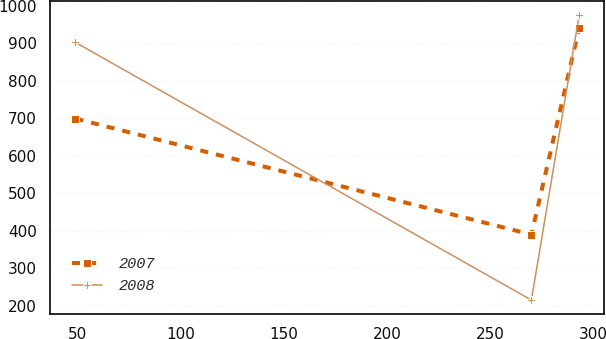Convert chart to OTSL. <chart><loc_0><loc_0><loc_500><loc_500><line_chart><ecel><fcel>2007<fcel>2008<nl><fcel>49.19<fcel>699.41<fcel>902.49<nl><fcel>269.81<fcel>390.43<fcel>215.91<nl><fcel>292.96<fcel>941.69<fcel>975.69<nl></chart> 